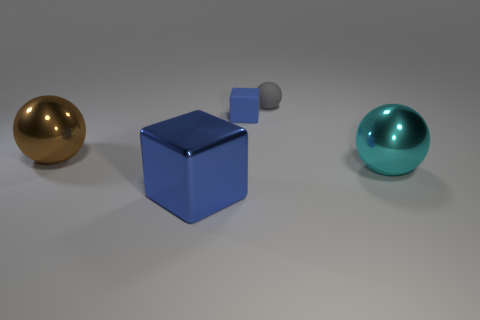What number of shiny things are small gray balls or yellow cubes?
Provide a short and direct response. 0. What color is the other metal object that is the same shape as the tiny blue thing?
Offer a very short reply. Blue. Are any big red metallic things visible?
Your answer should be very brief. No. Do the sphere behind the brown metal thing and the object that is to the right of the gray object have the same material?
Keep it short and to the point. No. What is the shape of the large thing that is the same color as the small block?
Offer a terse response. Cube. How many things are either blue blocks in front of the brown thing or objects in front of the blue rubber block?
Your answer should be very brief. 3. There is a big thing that is to the right of the gray matte sphere; is it the same color as the block that is behind the large brown object?
Offer a very short reply. No. There is a thing that is both on the right side of the small block and in front of the rubber sphere; what shape is it?
Provide a succinct answer. Sphere. What color is the matte thing that is the same size as the rubber block?
Keep it short and to the point. Gray. Is there a rubber cube of the same color as the small ball?
Provide a short and direct response. No. 